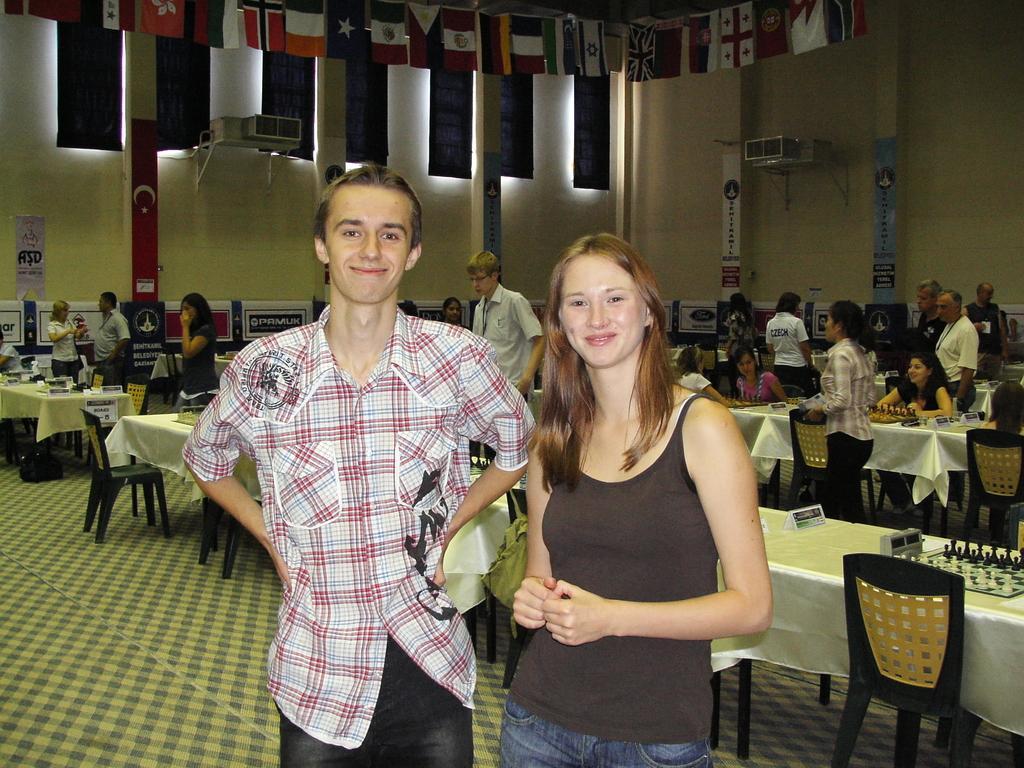Can you describe this image briefly? This image is taken inside a room. There are many persons in this room. At the top of the image flags are tied to a rope. At the bottom of the image there is a matted floor. In the right side of the image there are tables and chairs and on the table there is a chess board with chess coins. Few of them were playing chess. In the middle of the image man and woman are standing with a smiling face. At the background there is a wall with banners. 